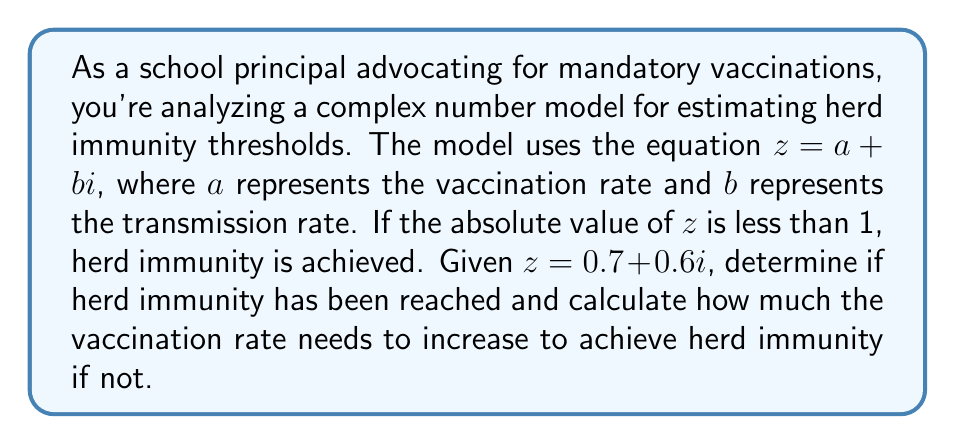Could you help me with this problem? 1) To determine if herd immunity is achieved, we need to calculate $|z|$:

   $|z| = \sqrt{a^2 + b^2} = \sqrt{0.7^2 + 0.6^2} = \sqrt{0.49 + 0.36} = \sqrt{0.85} \approx 0.9220$

2) Since $|z| \approx 0.9220 < 1$, herd immunity has been achieved.

3) However, to illustrate the process of increasing vaccination rate if needed:

   Let $x$ be the increase in vaccination rate needed. We want:

   $|(0.7+x) + 0.6i| = 1$

4) Using the absolute value formula:

   $\sqrt{(0.7+x)^2 + 0.6^2} = 1$

5) Simplifying:

   $(0.7+x)^2 + 0.36 = 1$
   $(0.7+x)^2 = 0.64$
   $0.7+x = \sqrt{0.64} = 0.8$

6) Solving for $x$:

   $x = 0.8 - 0.7 = 0.1$

7) Therefore, if herd immunity hadn't been achieved, the vaccination rate would need to increase by 0.1 or 10%.
Answer: Herd immunity achieved; no increase needed. 